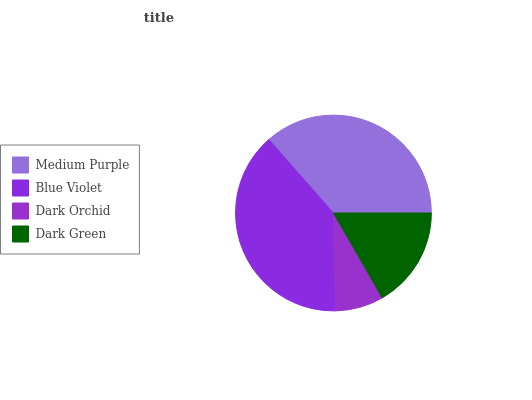Is Dark Orchid the minimum?
Answer yes or no. Yes. Is Blue Violet the maximum?
Answer yes or no. Yes. Is Blue Violet the minimum?
Answer yes or no. No. Is Dark Orchid the maximum?
Answer yes or no. No. Is Blue Violet greater than Dark Orchid?
Answer yes or no. Yes. Is Dark Orchid less than Blue Violet?
Answer yes or no. Yes. Is Dark Orchid greater than Blue Violet?
Answer yes or no. No. Is Blue Violet less than Dark Orchid?
Answer yes or no. No. Is Medium Purple the high median?
Answer yes or no. Yes. Is Dark Green the low median?
Answer yes or no. Yes. Is Dark Green the high median?
Answer yes or no. No. Is Blue Violet the low median?
Answer yes or no. No. 